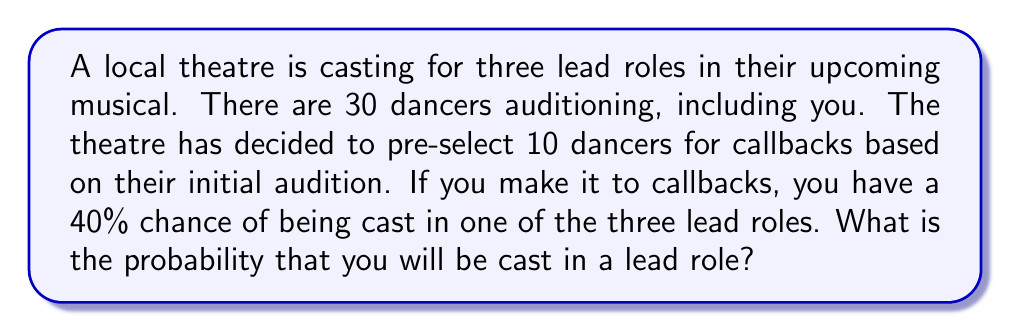Provide a solution to this math problem. Let's approach this problem step-by-step using set theory and probability concepts:

1) First, we need to calculate the probability of being selected for callbacks:
   $P(\text{callback}) = \frac{\text{number of dancers selected for callback}}{\text{total number of dancers}}$
   $P(\text{callback}) = \frac{10}{30} = \frac{1}{3}$

2) We're given that if you make it to callbacks, you have a 40% chance of being cast in a lead role. This can be written as:
   $P(\text{cast} | \text{callback}) = 0.40$

3) To find the overall probability of being cast, we need to use the law of total probability:
   $P(\text{cast}) = P(\text{cast} | \text{callback}) \cdot P(\text{callback})$

4) Substituting the values we know:
   $P(\text{cast}) = 0.40 \cdot \frac{1}{3}$

5) Calculating:
   $P(\text{cast}) = \frac{0.40}{3} = \frac{2}{15} = 0.1333...$

Therefore, the probability of being cast in a lead role is approximately 0.1333 or 13.33%.
Answer: $\frac{2}{15}$ or approximately $0.1333$ or $13.33\%$ 